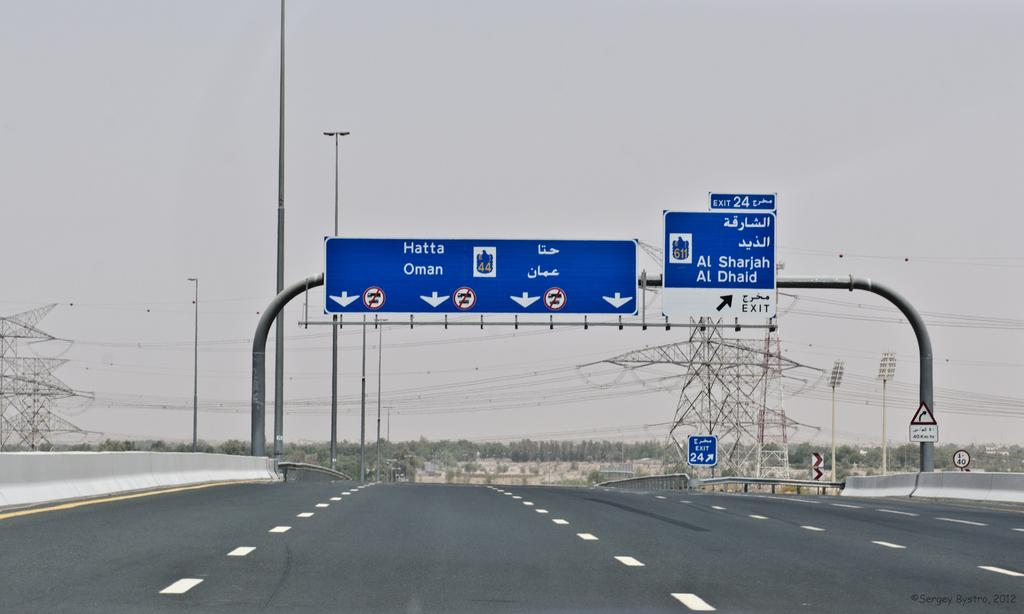<image>
Describe the image concisely. a five laned road to Hatta Oman is empty 